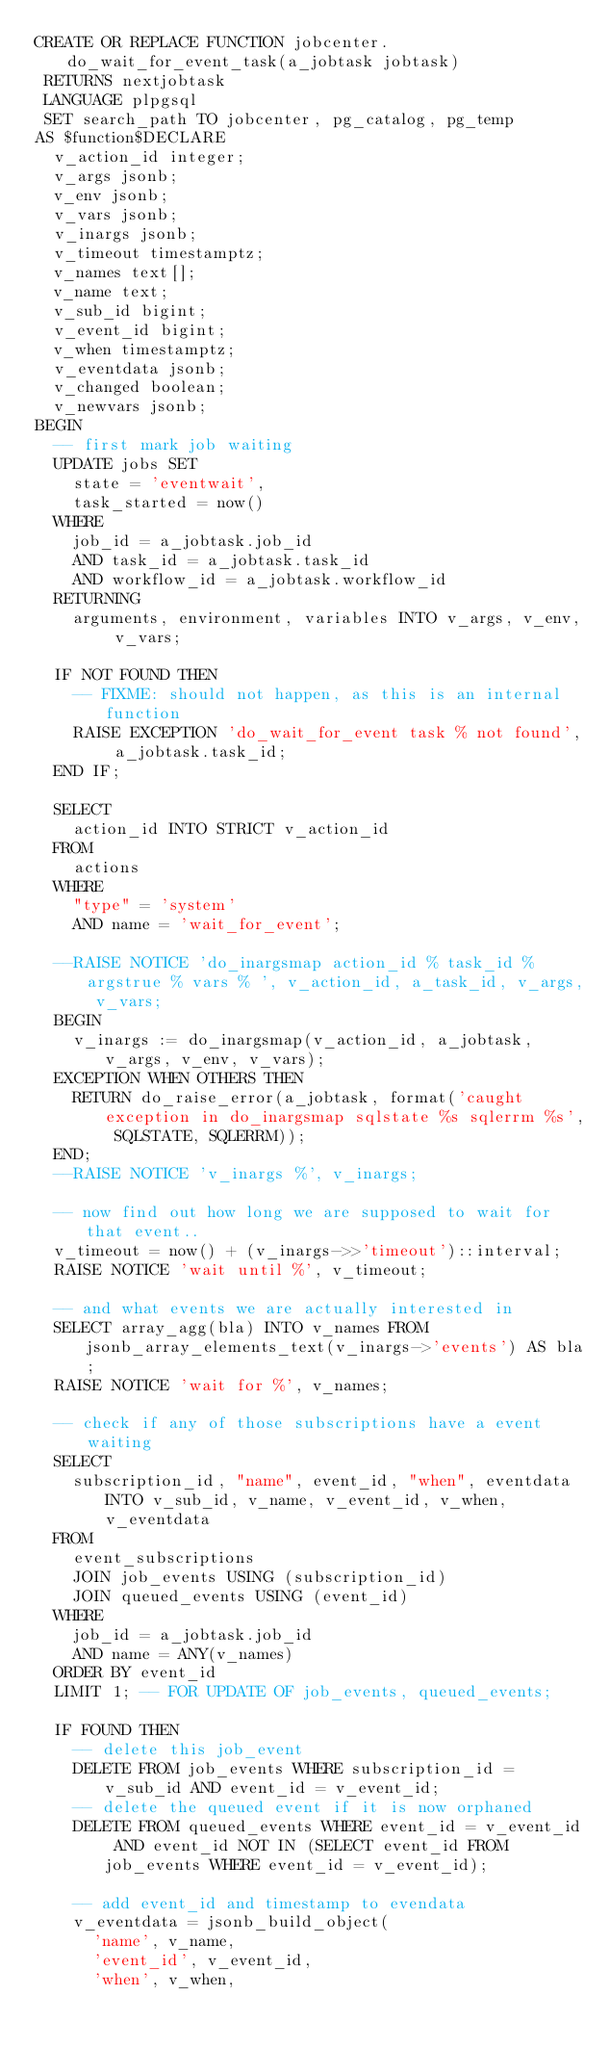<code> <loc_0><loc_0><loc_500><loc_500><_SQL_>CREATE OR REPLACE FUNCTION jobcenter.do_wait_for_event_task(a_jobtask jobtask)
 RETURNS nextjobtask
 LANGUAGE plpgsql
 SET search_path TO jobcenter, pg_catalog, pg_temp
AS $function$DECLARE
	v_action_id integer;
	v_args jsonb;
	v_env jsonb;
	v_vars jsonb;
	v_inargs jsonb;
	v_timeout timestamptz;
	v_names text[];
	v_name text;
	v_sub_id bigint;
	v_event_id bigint;
	v_when timestamptz;
	v_eventdata jsonb;
	v_changed boolean;
	v_newvars jsonb;
BEGIN
	-- first mark job waiting
	UPDATE jobs SET
		state = 'eventwait',
		task_started = now()
	WHERE
		job_id = a_jobtask.job_id
		AND task_id = a_jobtask.task_id
		AND workflow_id = a_jobtask.workflow_id
	RETURNING
		arguments, environment, variables INTO v_args, v_env, v_vars;

	IF NOT FOUND THEN
		-- FIXME: should not happen, as this is an internal function
		RAISE EXCEPTION 'do_wait_for_event task % not found', a_jobtask.task_id;
	END IF;

	SELECT
		action_id INTO STRICT v_action_id
	FROM
		actions
	WHERE
		"type" = 'system'
		AND name = 'wait_for_event';
	
	--RAISE NOTICE 'do_inargsmap action_id % task_id % argstrue % vars % ', v_action_id, a_task_id, v_args, v_vars;
	BEGIN
		v_inargs := do_inargsmap(v_action_id, a_jobtask, v_args, v_env, v_vars);
	EXCEPTION WHEN OTHERS THEN
		RETURN do_raise_error(a_jobtask, format('caught exception in do_inargsmap sqlstate %s sqlerrm %s', SQLSTATE, SQLERRM));
	END;	
	--RAISE NOTICE 'v_inargs %', v_inargs;

	-- now find out how long we are supposed to wait for that event..
	v_timeout = now() + (v_inargs->>'timeout')::interval;
	RAISE NOTICE 'wait until %', v_timeout;

	-- and what events we are actually interested in
	SELECT array_agg(bla) INTO v_names FROM jsonb_array_elements_text(v_inargs->'events') AS bla;
	RAISE NOTICE 'wait for %', v_names;

	-- check if any of those subscriptions have a event waiting
	SELECT
		subscription_id, "name", event_id, "when", eventdata INTO v_sub_id, v_name, v_event_id, v_when, v_eventdata
	FROM
		event_subscriptions
		JOIN job_events USING (subscription_id)
		JOIN queued_events USING (event_id)
	WHERE
		job_id = a_jobtask.job_id
		AND name = ANY(v_names)
	ORDER BY event_id
	LIMIT 1; -- FOR UPDATE OF job_events, queued_events;

	IF FOUND THEN
		-- delete this job_event
		DELETE FROM job_events WHERE subscription_id = v_sub_id AND event_id = v_event_id;
		-- delete the queued event if it is now orphaned
		DELETE FROM queued_events WHERE event_id = v_event_id AND event_id NOT IN (SELECT event_id FROM job_events WHERE event_id = v_event_id);

		-- add event_id and timestamp to evendata
		v_eventdata = jsonb_build_object(
			'name', v_name,
			'event_id', v_event_id,
			'when', v_when,</code> 